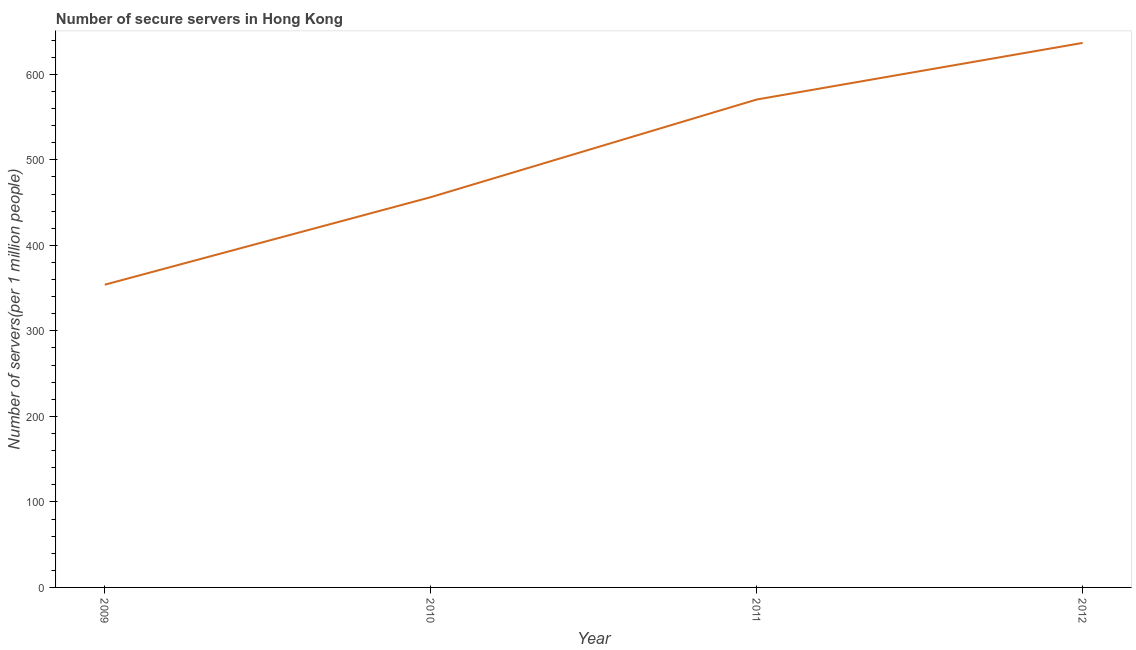What is the number of secure internet servers in 2012?
Give a very brief answer. 636.65. Across all years, what is the maximum number of secure internet servers?
Give a very brief answer. 636.65. Across all years, what is the minimum number of secure internet servers?
Your response must be concise. 353.95. In which year was the number of secure internet servers minimum?
Provide a short and direct response. 2009. What is the sum of the number of secure internet servers?
Keep it short and to the point. 2017.33. What is the difference between the number of secure internet servers in 2009 and 2012?
Give a very brief answer. -282.71. What is the average number of secure internet servers per year?
Keep it short and to the point. 504.33. What is the median number of secure internet servers?
Ensure brevity in your answer.  513.37. In how many years, is the number of secure internet servers greater than 60 ?
Offer a very short reply. 4. Do a majority of the years between 2010 and 2009 (inclusive) have number of secure internet servers greater than 300 ?
Give a very brief answer. No. What is the ratio of the number of secure internet servers in 2010 to that in 2011?
Your response must be concise. 0.8. Is the difference between the number of secure internet servers in 2010 and 2011 greater than the difference between any two years?
Give a very brief answer. No. What is the difference between the highest and the second highest number of secure internet servers?
Your response must be concise. 66.2. Is the sum of the number of secure internet servers in 2011 and 2012 greater than the maximum number of secure internet servers across all years?
Ensure brevity in your answer.  Yes. What is the difference between the highest and the lowest number of secure internet servers?
Ensure brevity in your answer.  282.71. In how many years, is the number of secure internet servers greater than the average number of secure internet servers taken over all years?
Keep it short and to the point. 2. Does the number of secure internet servers monotonically increase over the years?
Your answer should be compact. Yes. How many years are there in the graph?
Your response must be concise. 4. What is the difference between two consecutive major ticks on the Y-axis?
Ensure brevity in your answer.  100. Are the values on the major ticks of Y-axis written in scientific E-notation?
Your response must be concise. No. Does the graph contain grids?
Your answer should be very brief. No. What is the title of the graph?
Give a very brief answer. Number of secure servers in Hong Kong. What is the label or title of the X-axis?
Give a very brief answer. Year. What is the label or title of the Y-axis?
Offer a terse response. Number of servers(per 1 million people). What is the Number of servers(per 1 million people) of 2009?
Your response must be concise. 353.95. What is the Number of servers(per 1 million people) of 2010?
Provide a short and direct response. 456.28. What is the Number of servers(per 1 million people) in 2011?
Your answer should be very brief. 570.45. What is the Number of servers(per 1 million people) of 2012?
Your answer should be very brief. 636.65. What is the difference between the Number of servers(per 1 million people) in 2009 and 2010?
Offer a terse response. -102.33. What is the difference between the Number of servers(per 1 million people) in 2009 and 2011?
Your answer should be compact. -216.5. What is the difference between the Number of servers(per 1 million people) in 2009 and 2012?
Offer a terse response. -282.71. What is the difference between the Number of servers(per 1 million people) in 2010 and 2011?
Your answer should be very brief. -114.17. What is the difference between the Number of servers(per 1 million people) in 2010 and 2012?
Give a very brief answer. -180.37. What is the difference between the Number of servers(per 1 million people) in 2011 and 2012?
Keep it short and to the point. -66.2. What is the ratio of the Number of servers(per 1 million people) in 2009 to that in 2010?
Give a very brief answer. 0.78. What is the ratio of the Number of servers(per 1 million people) in 2009 to that in 2011?
Make the answer very short. 0.62. What is the ratio of the Number of servers(per 1 million people) in 2009 to that in 2012?
Provide a short and direct response. 0.56. What is the ratio of the Number of servers(per 1 million people) in 2010 to that in 2012?
Your answer should be very brief. 0.72. What is the ratio of the Number of servers(per 1 million people) in 2011 to that in 2012?
Ensure brevity in your answer.  0.9. 